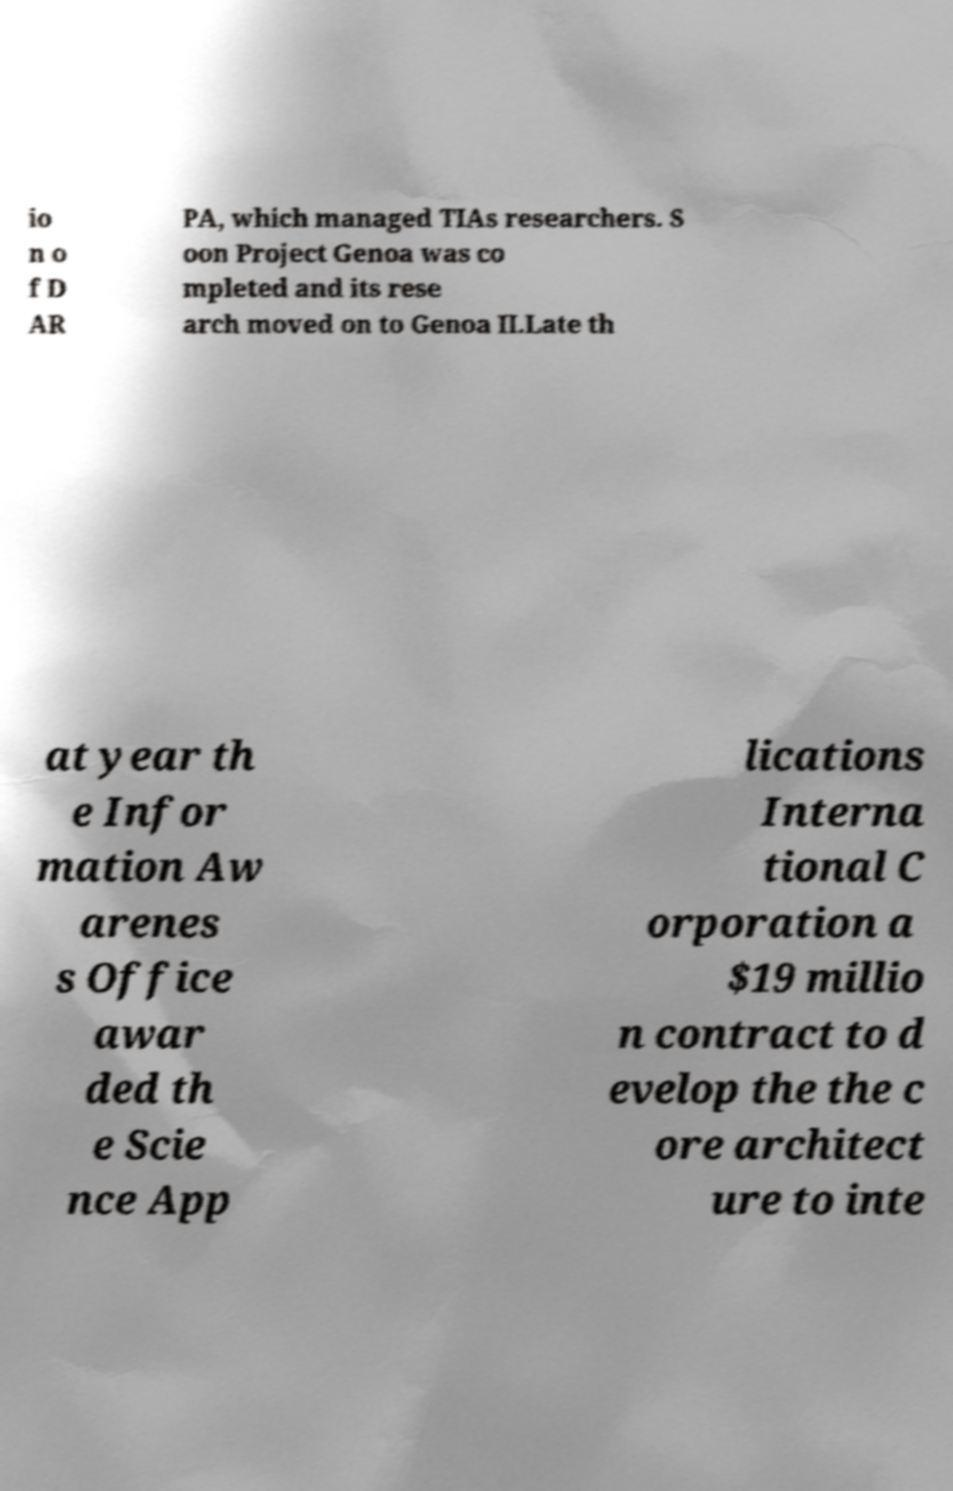Can you read and provide the text displayed in the image?This photo seems to have some interesting text. Can you extract and type it out for me? io n o f D AR PA, which managed TIAs researchers. S oon Project Genoa was co mpleted and its rese arch moved on to Genoa II.Late th at year th e Infor mation Aw arenes s Office awar ded th e Scie nce App lications Interna tional C orporation a $19 millio n contract to d evelop the the c ore architect ure to inte 